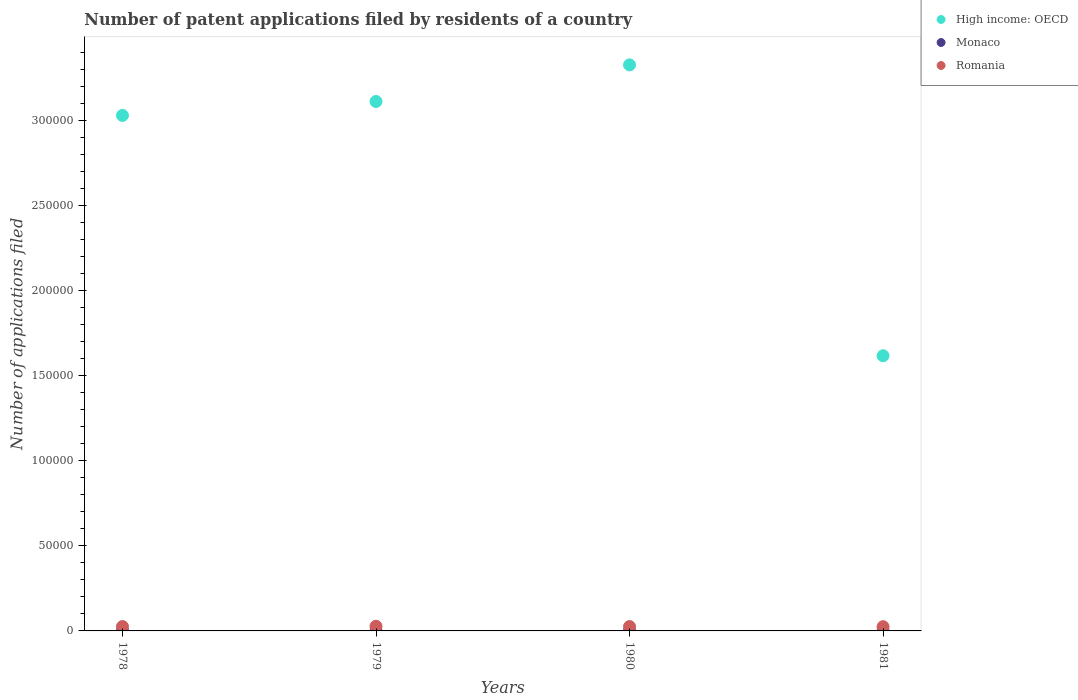How many different coloured dotlines are there?
Provide a succinct answer. 3. What is the number of applications filed in Monaco in 1981?
Make the answer very short. 20. Across all years, what is the maximum number of applications filed in Monaco?
Offer a very short reply. 30. Across all years, what is the minimum number of applications filed in High income: OECD?
Give a very brief answer. 1.62e+05. In which year was the number of applications filed in High income: OECD maximum?
Offer a very short reply. 1980. What is the total number of applications filed in Monaco in the graph?
Your answer should be compact. 81. What is the difference between the number of applications filed in High income: OECD in 1981 and the number of applications filed in Romania in 1978?
Your answer should be very brief. 1.59e+05. What is the average number of applications filed in Romania per year?
Keep it short and to the point. 2592.25. In the year 1979, what is the difference between the number of applications filed in Monaco and number of applications filed in Romania?
Provide a succinct answer. -2734. In how many years, is the number of applications filed in Monaco greater than 130000?
Your response must be concise. 0. What is the ratio of the number of applications filed in Romania in 1980 to that in 1981?
Make the answer very short. 1.04. Is the difference between the number of applications filed in Monaco in 1979 and 1980 greater than the difference between the number of applications filed in Romania in 1979 and 1980?
Your answer should be compact. No. What is the difference between the highest and the second highest number of applications filed in Monaco?
Provide a succinct answer. 10. What is the difference between the highest and the lowest number of applications filed in Romania?
Your answer should be very brief. 270. Is the sum of the number of applications filed in Monaco in 1979 and 1981 greater than the maximum number of applications filed in High income: OECD across all years?
Ensure brevity in your answer.  No. Is the number of applications filed in Monaco strictly less than the number of applications filed in High income: OECD over the years?
Make the answer very short. Yes. How many dotlines are there?
Your answer should be compact. 3. How many years are there in the graph?
Offer a terse response. 4. Are the values on the major ticks of Y-axis written in scientific E-notation?
Your answer should be compact. No. Does the graph contain any zero values?
Provide a short and direct response. No. What is the title of the graph?
Offer a terse response. Number of patent applications filed by residents of a country. What is the label or title of the Y-axis?
Offer a very short reply. Number of applications filed. What is the Number of applications filed of High income: OECD in 1978?
Your answer should be compact. 3.03e+05. What is the Number of applications filed in Monaco in 1978?
Offer a very short reply. 30. What is the Number of applications filed of Romania in 1978?
Provide a succinct answer. 2568. What is the Number of applications filed of High income: OECD in 1979?
Your response must be concise. 3.11e+05. What is the Number of applications filed in Monaco in 1979?
Ensure brevity in your answer.  17. What is the Number of applications filed in Romania in 1979?
Ensure brevity in your answer.  2751. What is the Number of applications filed in High income: OECD in 1980?
Offer a terse response. 3.33e+05. What is the Number of applications filed of Romania in 1980?
Provide a succinct answer. 2569. What is the Number of applications filed in High income: OECD in 1981?
Offer a very short reply. 1.62e+05. What is the Number of applications filed in Monaco in 1981?
Keep it short and to the point. 20. What is the Number of applications filed of Romania in 1981?
Make the answer very short. 2481. Across all years, what is the maximum Number of applications filed of High income: OECD?
Provide a succinct answer. 3.33e+05. Across all years, what is the maximum Number of applications filed of Romania?
Offer a terse response. 2751. Across all years, what is the minimum Number of applications filed of High income: OECD?
Your response must be concise. 1.62e+05. Across all years, what is the minimum Number of applications filed in Romania?
Ensure brevity in your answer.  2481. What is the total Number of applications filed in High income: OECD in the graph?
Give a very brief answer. 1.11e+06. What is the total Number of applications filed of Romania in the graph?
Offer a terse response. 1.04e+04. What is the difference between the Number of applications filed of High income: OECD in 1978 and that in 1979?
Keep it short and to the point. -8179. What is the difference between the Number of applications filed of Monaco in 1978 and that in 1979?
Ensure brevity in your answer.  13. What is the difference between the Number of applications filed of Romania in 1978 and that in 1979?
Make the answer very short. -183. What is the difference between the Number of applications filed of High income: OECD in 1978 and that in 1980?
Your answer should be very brief. -2.97e+04. What is the difference between the Number of applications filed of Romania in 1978 and that in 1980?
Provide a succinct answer. -1. What is the difference between the Number of applications filed in High income: OECD in 1978 and that in 1981?
Offer a terse response. 1.41e+05. What is the difference between the Number of applications filed in Romania in 1978 and that in 1981?
Provide a succinct answer. 87. What is the difference between the Number of applications filed of High income: OECD in 1979 and that in 1980?
Your response must be concise. -2.15e+04. What is the difference between the Number of applications filed of Monaco in 1979 and that in 1980?
Keep it short and to the point. 3. What is the difference between the Number of applications filed of Romania in 1979 and that in 1980?
Provide a succinct answer. 182. What is the difference between the Number of applications filed of High income: OECD in 1979 and that in 1981?
Make the answer very short. 1.49e+05. What is the difference between the Number of applications filed of Romania in 1979 and that in 1981?
Your answer should be compact. 270. What is the difference between the Number of applications filed in High income: OECD in 1980 and that in 1981?
Provide a short and direct response. 1.71e+05. What is the difference between the Number of applications filed in Monaco in 1980 and that in 1981?
Offer a very short reply. -6. What is the difference between the Number of applications filed in Romania in 1980 and that in 1981?
Give a very brief answer. 88. What is the difference between the Number of applications filed of High income: OECD in 1978 and the Number of applications filed of Monaco in 1979?
Provide a succinct answer. 3.03e+05. What is the difference between the Number of applications filed of High income: OECD in 1978 and the Number of applications filed of Romania in 1979?
Your response must be concise. 3.00e+05. What is the difference between the Number of applications filed of Monaco in 1978 and the Number of applications filed of Romania in 1979?
Provide a short and direct response. -2721. What is the difference between the Number of applications filed in High income: OECD in 1978 and the Number of applications filed in Monaco in 1980?
Your answer should be compact. 3.03e+05. What is the difference between the Number of applications filed in High income: OECD in 1978 and the Number of applications filed in Romania in 1980?
Give a very brief answer. 3.00e+05. What is the difference between the Number of applications filed of Monaco in 1978 and the Number of applications filed of Romania in 1980?
Your answer should be compact. -2539. What is the difference between the Number of applications filed of High income: OECD in 1978 and the Number of applications filed of Monaco in 1981?
Keep it short and to the point. 3.03e+05. What is the difference between the Number of applications filed of High income: OECD in 1978 and the Number of applications filed of Romania in 1981?
Your answer should be compact. 3.00e+05. What is the difference between the Number of applications filed in Monaco in 1978 and the Number of applications filed in Romania in 1981?
Ensure brevity in your answer.  -2451. What is the difference between the Number of applications filed in High income: OECD in 1979 and the Number of applications filed in Monaco in 1980?
Offer a terse response. 3.11e+05. What is the difference between the Number of applications filed in High income: OECD in 1979 and the Number of applications filed in Romania in 1980?
Give a very brief answer. 3.09e+05. What is the difference between the Number of applications filed of Monaco in 1979 and the Number of applications filed of Romania in 1980?
Make the answer very short. -2552. What is the difference between the Number of applications filed in High income: OECD in 1979 and the Number of applications filed in Monaco in 1981?
Offer a very short reply. 3.11e+05. What is the difference between the Number of applications filed in High income: OECD in 1979 and the Number of applications filed in Romania in 1981?
Offer a very short reply. 3.09e+05. What is the difference between the Number of applications filed in Monaco in 1979 and the Number of applications filed in Romania in 1981?
Make the answer very short. -2464. What is the difference between the Number of applications filed in High income: OECD in 1980 and the Number of applications filed in Monaco in 1981?
Ensure brevity in your answer.  3.33e+05. What is the difference between the Number of applications filed of High income: OECD in 1980 and the Number of applications filed of Romania in 1981?
Your answer should be compact. 3.30e+05. What is the difference between the Number of applications filed in Monaco in 1980 and the Number of applications filed in Romania in 1981?
Provide a short and direct response. -2467. What is the average Number of applications filed of High income: OECD per year?
Provide a short and direct response. 2.77e+05. What is the average Number of applications filed in Monaco per year?
Provide a short and direct response. 20.25. What is the average Number of applications filed of Romania per year?
Give a very brief answer. 2592.25. In the year 1978, what is the difference between the Number of applications filed in High income: OECD and Number of applications filed in Monaco?
Offer a terse response. 3.03e+05. In the year 1978, what is the difference between the Number of applications filed of High income: OECD and Number of applications filed of Romania?
Your response must be concise. 3.00e+05. In the year 1978, what is the difference between the Number of applications filed in Monaco and Number of applications filed in Romania?
Provide a short and direct response. -2538. In the year 1979, what is the difference between the Number of applications filed in High income: OECD and Number of applications filed in Monaco?
Offer a terse response. 3.11e+05. In the year 1979, what is the difference between the Number of applications filed in High income: OECD and Number of applications filed in Romania?
Your answer should be compact. 3.08e+05. In the year 1979, what is the difference between the Number of applications filed of Monaco and Number of applications filed of Romania?
Offer a very short reply. -2734. In the year 1980, what is the difference between the Number of applications filed of High income: OECD and Number of applications filed of Monaco?
Offer a terse response. 3.33e+05. In the year 1980, what is the difference between the Number of applications filed in High income: OECD and Number of applications filed in Romania?
Provide a short and direct response. 3.30e+05. In the year 1980, what is the difference between the Number of applications filed in Monaco and Number of applications filed in Romania?
Your response must be concise. -2555. In the year 1981, what is the difference between the Number of applications filed of High income: OECD and Number of applications filed of Monaco?
Your answer should be very brief. 1.62e+05. In the year 1981, what is the difference between the Number of applications filed in High income: OECD and Number of applications filed in Romania?
Provide a short and direct response. 1.59e+05. In the year 1981, what is the difference between the Number of applications filed of Monaco and Number of applications filed of Romania?
Make the answer very short. -2461. What is the ratio of the Number of applications filed of High income: OECD in 1978 to that in 1979?
Make the answer very short. 0.97. What is the ratio of the Number of applications filed in Monaco in 1978 to that in 1979?
Your answer should be very brief. 1.76. What is the ratio of the Number of applications filed of Romania in 1978 to that in 1979?
Provide a short and direct response. 0.93. What is the ratio of the Number of applications filed in High income: OECD in 1978 to that in 1980?
Your answer should be compact. 0.91. What is the ratio of the Number of applications filed in Monaco in 1978 to that in 1980?
Your answer should be compact. 2.14. What is the ratio of the Number of applications filed of High income: OECD in 1978 to that in 1981?
Give a very brief answer. 1.87. What is the ratio of the Number of applications filed of Monaco in 1978 to that in 1981?
Provide a succinct answer. 1.5. What is the ratio of the Number of applications filed in Romania in 1978 to that in 1981?
Keep it short and to the point. 1.04. What is the ratio of the Number of applications filed of High income: OECD in 1979 to that in 1980?
Your answer should be compact. 0.94. What is the ratio of the Number of applications filed of Monaco in 1979 to that in 1980?
Offer a very short reply. 1.21. What is the ratio of the Number of applications filed of Romania in 1979 to that in 1980?
Provide a succinct answer. 1.07. What is the ratio of the Number of applications filed in High income: OECD in 1979 to that in 1981?
Your answer should be compact. 1.92. What is the ratio of the Number of applications filed of Romania in 1979 to that in 1981?
Provide a short and direct response. 1.11. What is the ratio of the Number of applications filed of High income: OECD in 1980 to that in 1981?
Give a very brief answer. 2.06. What is the ratio of the Number of applications filed in Romania in 1980 to that in 1981?
Ensure brevity in your answer.  1.04. What is the difference between the highest and the second highest Number of applications filed in High income: OECD?
Your answer should be compact. 2.15e+04. What is the difference between the highest and the second highest Number of applications filed of Monaco?
Offer a very short reply. 10. What is the difference between the highest and the second highest Number of applications filed of Romania?
Offer a very short reply. 182. What is the difference between the highest and the lowest Number of applications filed of High income: OECD?
Provide a short and direct response. 1.71e+05. What is the difference between the highest and the lowest Number of applications filed of Romania?
Your answer should be compact. 270. 